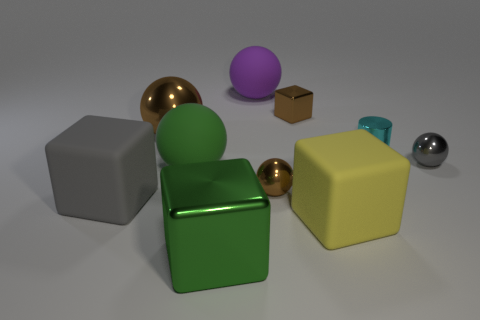Subtract all small metal cubes. How many cubes are left? 3 Subtract all brown spheres. How many spheres are left? 3 Subtract all cylinders. How many objects are left? 9 Subtract 4 blocks. How many blocks are left? 0 Subtract all small brown metallic spheres. Subtract all green rubber objects. How many objects are left? 8 Add 4 purple spheres. How many purple spheres are left? 5 Add 8 big purple things. How many big purple things exist? 9 Subtract 1 green cubes. How many objects are left? 9 Subtract all green cubes. Subtract all brown balls. How many cubes are left? 3 Subtract all yellow cylinders. How many yellow blocks are left? 1 